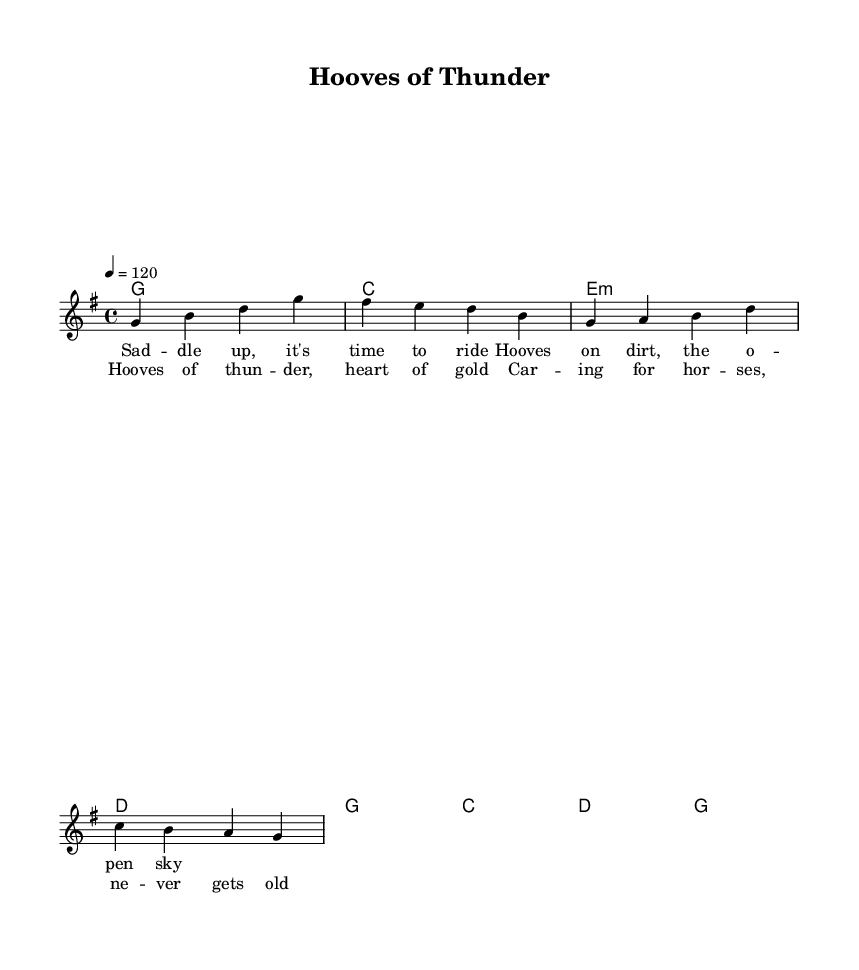What is the key signature of this music? The key signature indicates G major, which has one sharp (F#). This can be identified by looking at the key signature at the beginning of the staff.
Answer: G major What is the time signature of this piece? The time signature is 4/4, as indicated at the beginning of the score. This means there are four beats in each measure, and a quarter note receives one beat.
Answer: 4/4 How many measures are in the melody section? Counting the measures indicated in the melody part, there are four complete measures. Each vertical bar line represents the end of a measure.
Answer: 4 What is the tempo marking of this piece? The tempo marking is 120 beats per minute, indicated at the beginning of the score. This specifies the speed of the music, guiding performers on how fast to play.
Answer: 120 What is the first lyric in the verse? The first lyric in the verse is "Saddle up, it's time to ride," which is the first line of the lyrics associated with the melody.
Answer: Saddle up, it's time to ride What chord is played on the third measure of the harmonies? The chord played in the third measure of harmonies is E minor, indicated by the 'e:m' notation in the chord mode section.
Answer: E minor What theme does the chorus highlight? The chorus highlights themes of caring for horses and the joy in equestrian life, which is reflected in the lines "Hooves of thunder, heart of gold."
Answer: Caring for horses 